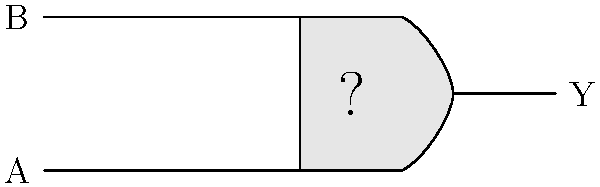In the digital circuit schematic shown above, what type of logic gate is represented? To identify the logic gate in this schematic, let's analyze its key features:

1. The gate has two input lines (A and B) entering from the left side.
2. There is one output line (Y) exiting from the right side.
3. The shape of the gate is distinctive: it has a flat left side and a curved right side, forming a D-like shape.

These characteristics are typical of an AND gate in digital logic. The AND gate performs the logical AND operation, where the output is true (1) only when both inputs are true (1).

While this may look different from the symbols used in more modern digital logic diagrams, this representation was common in older schematics and textbooks, especially around the 90s era.

For a 90s gamer, you might relate this to the idea of needing two correct inputs (like pressing two buttons simultaneously) to achieve a desired outcome in a game.
Answer: AND gate 